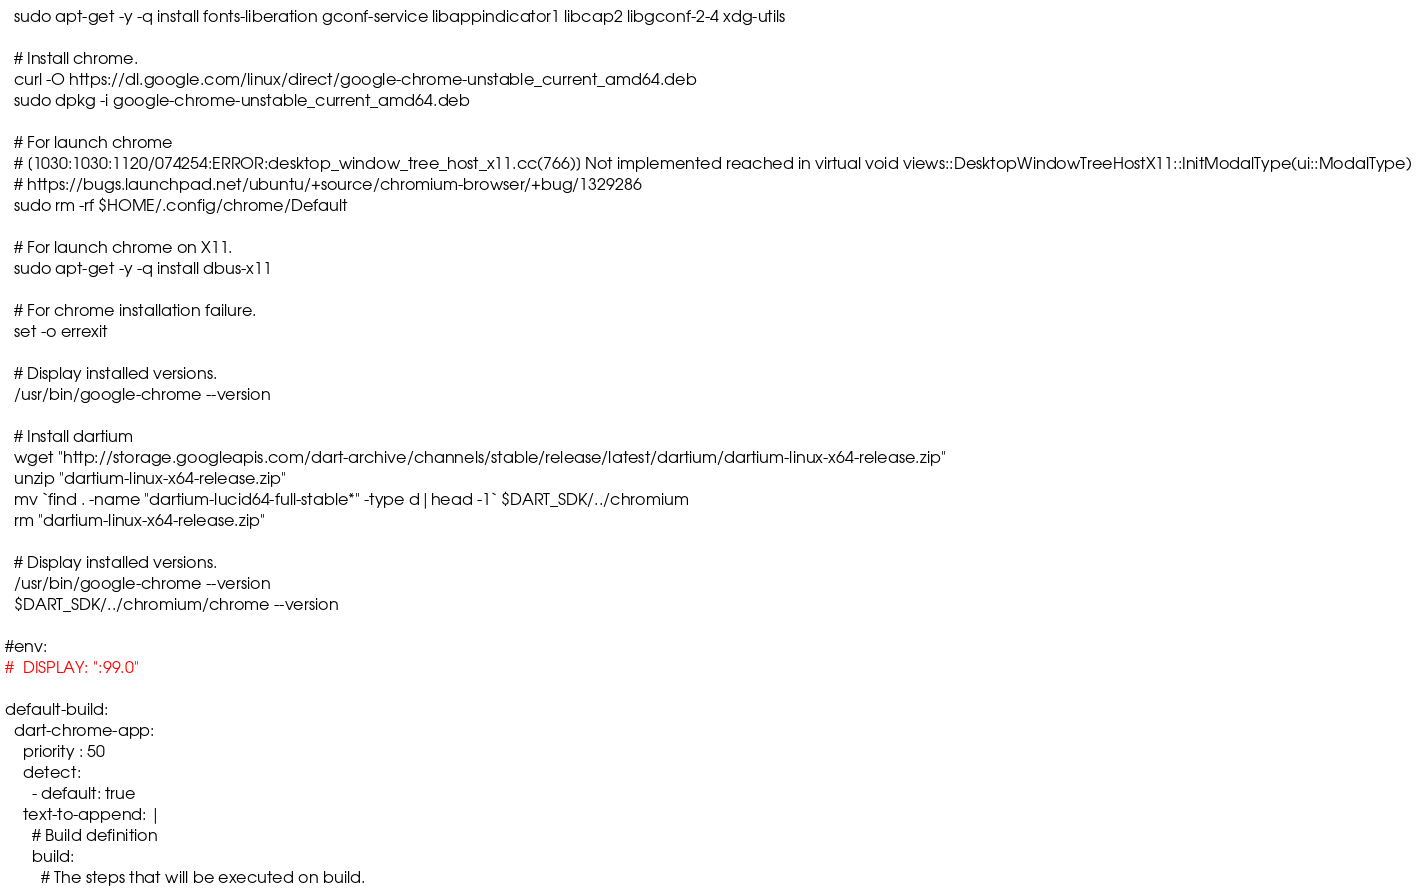<code> <loc_0><loc_0><loc_500><loc_500><_YAML_>  sudo apt-get -y -q install fonts-liberation gconf-service libappindicator1 libcap2 libgconf-2-4 xdg-utils

  # Install chrome.
  curl -O https://dl.google.com/linux/direct/google-chrome-unstable_current_amd64.deb
  sudo dpkg -i google-chrome-unstable_current_amd64.deb

  # For launch chrome
  # [1030:1030:1120/074254:ERROR:desktop_window_tree_host_x11.cc(766)] Not implemented reached in virtual void views::DesktopWindowTreeHostX11::InitModalType(ui::ModalType)
  # https://bugs.launchpad.net/ubuntu/+source/chromium-browser/+bug/1329286
  sudo rm -rf $HOME/.config/chrome/Default

  # For launch chrome on X11.
  sudo apt-get -y -q install dbus-x11

  # For chrome installation failure.
  set -o errexit

  # Display installed versions.
  /usr/bin/google-chrome --version

  # Install dartium
  wget "http://storage.googleapis.com/dart-archive/channels/stable/release/latest/dartium/dartium-linux-x64-release.zip"
  unzip "dartium-linux-x64-release.zip"
  mv `find . -name "dartium-lucid64-full-stable*" -type d|head -1` $DART_SDK/../chromium
  rm "dartium-linux-x64-release.zip"

  # Display installed versions.
  /usr/bin/google-chrome --version
  $DART_SDK/../chromium/chrome --version

#env:
#  DISPLAY: ":99.0"

default-build:
  dart-chrome-app:
    priority : 50
    detect:
      - default: true
    text-to-append: |
      # Build definition
      build:
        # The steps that will be executed on build.</code> 